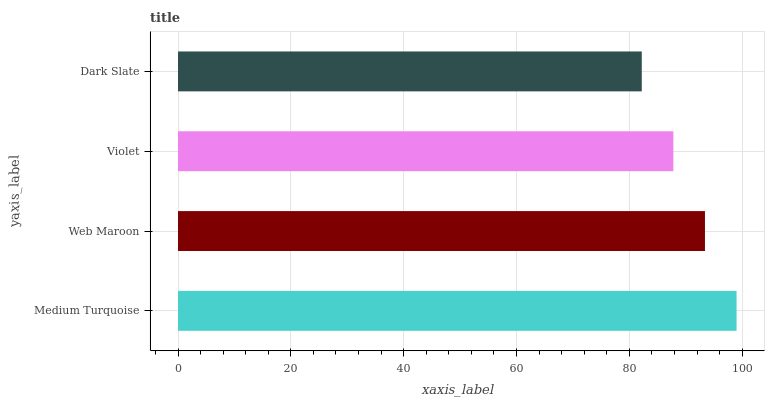Is Dark Slate the minimum?
Answer yes or no. Yes. Is Medium Turquoise the maximum?
Answer yes or no. Yes. Is Web Maroon the minimum?
Answer yes or no. No. Is Web Maroon the maximum?
Answer yes or no. No. Is Medium Turquoise greater than Web Maroon?
Answer yes or no. Yes. Is Web Maroon less than Medium Turquoise?
Answer yes or no. Yes. Is Web Maroon greater than Medium Turquoise?
Answer yes or no. No. Is Medium Turquoise less than Web Maroon?
Answer yes or no. No. Is Web Maroon the high median?
Answer yes or no. Yes. Is Violet the low median?
Answer yes or no. Yes. Is Dark Slate the high median?
Answer yes or no. No. Is Dark Slate the low median?
Answer yes or no. No. 